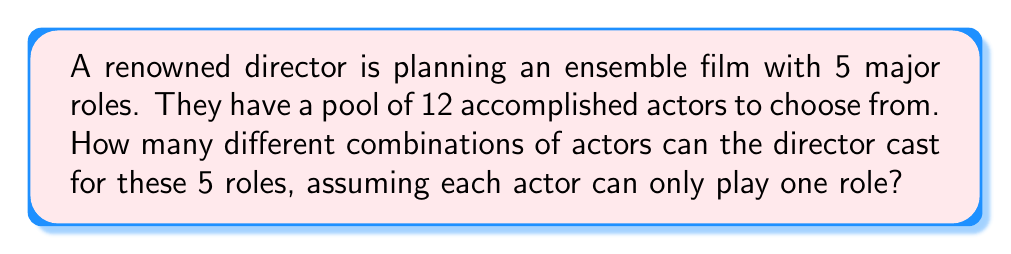Help me with this question. To solve this problem, we need to use the combination formula. Here's the step-by-step solution:

1) This scenario is a combination problem because the order of selection doesn't matter (it's not important which actor gets which specific role, just who is in the cast).

2) We are selecting 5 actors out of 12, where each actor can only be selected once.

3) The formula for combinations is:

   $$C(n,r) = \frac{n!}{r!(n-r)!}$$

   Where $n$ is the total number of items to choose from, and $r$ is the number of items being chosen.

4) In this case, $n = 12$ (total actors) and $r = 5$ (roles to fill).

5) Plugging these numbers into our formula:

   $$C(12,5) = \frac{12!}{5!(12-5)!} = \frac{12!}{5!(7)!}$$

6) Expanding this:
   
   $$\frac{12 \times 11 \times 10 \times 9 \times 8 \times 7!}{(5 \times 4 \times 3 \times 2 \times 1) \times 7!}$$

7) The 7! cancels out in the numerator and denominator:

   $$\frac{12 \times 11 \times 10 \times 9 \times 8}{5 \times 4 \times 3 \times 2 \times 1} = \frac{95,040}{120} = 792$$

Therefore, there are 792 different possible combinations of actors the director can choose for the 5 roles.
Answer: 792 